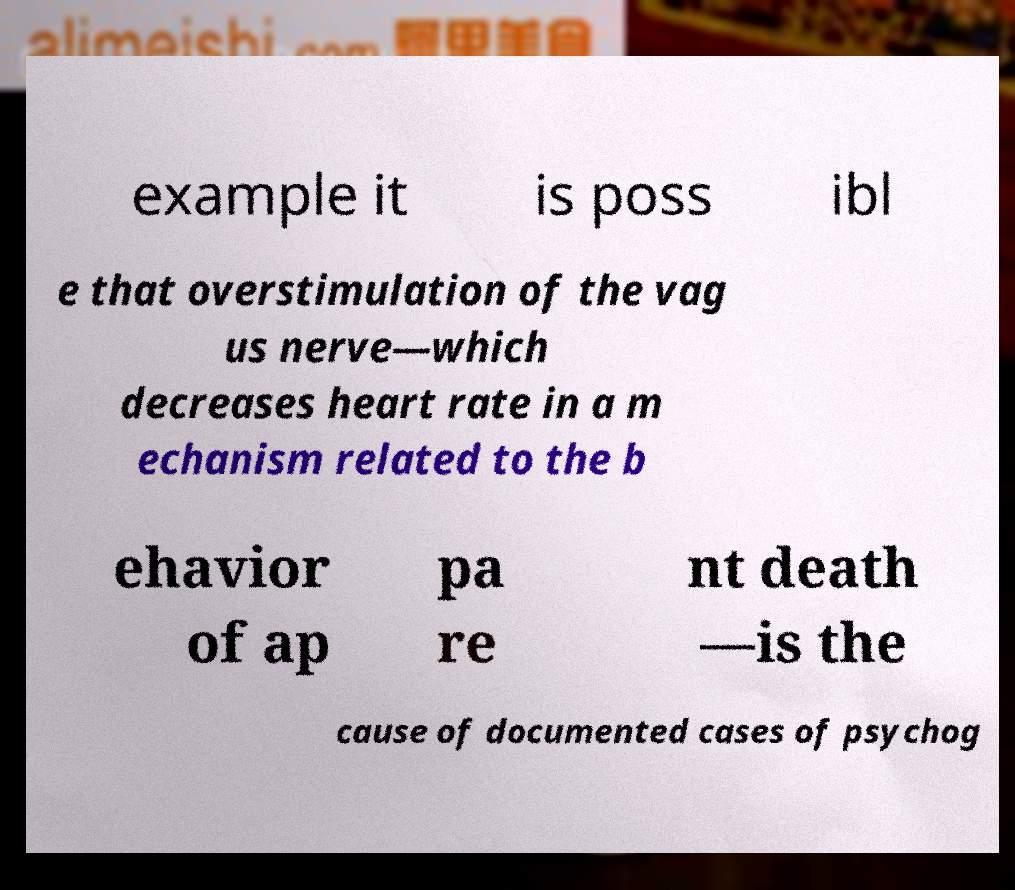There's text embedded in this image that I need extracted. Can you transcribe it verbatim? example it is poss ibl e that overstimulation of the vag us nerve—which decreases heart rate in a m echanism related to the b ehavior of ap pa re nt death —is the cause of documented cases of psychog 